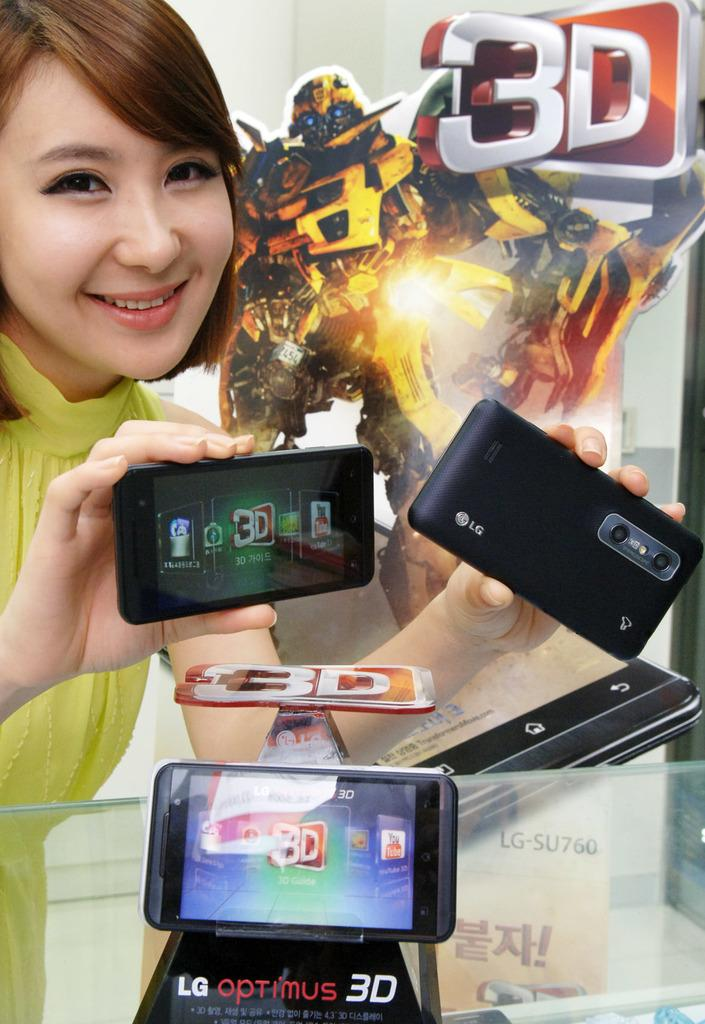<image>
Present a compact description of the photo's key features. A woman is holding up the phone LG Optimus 3D 